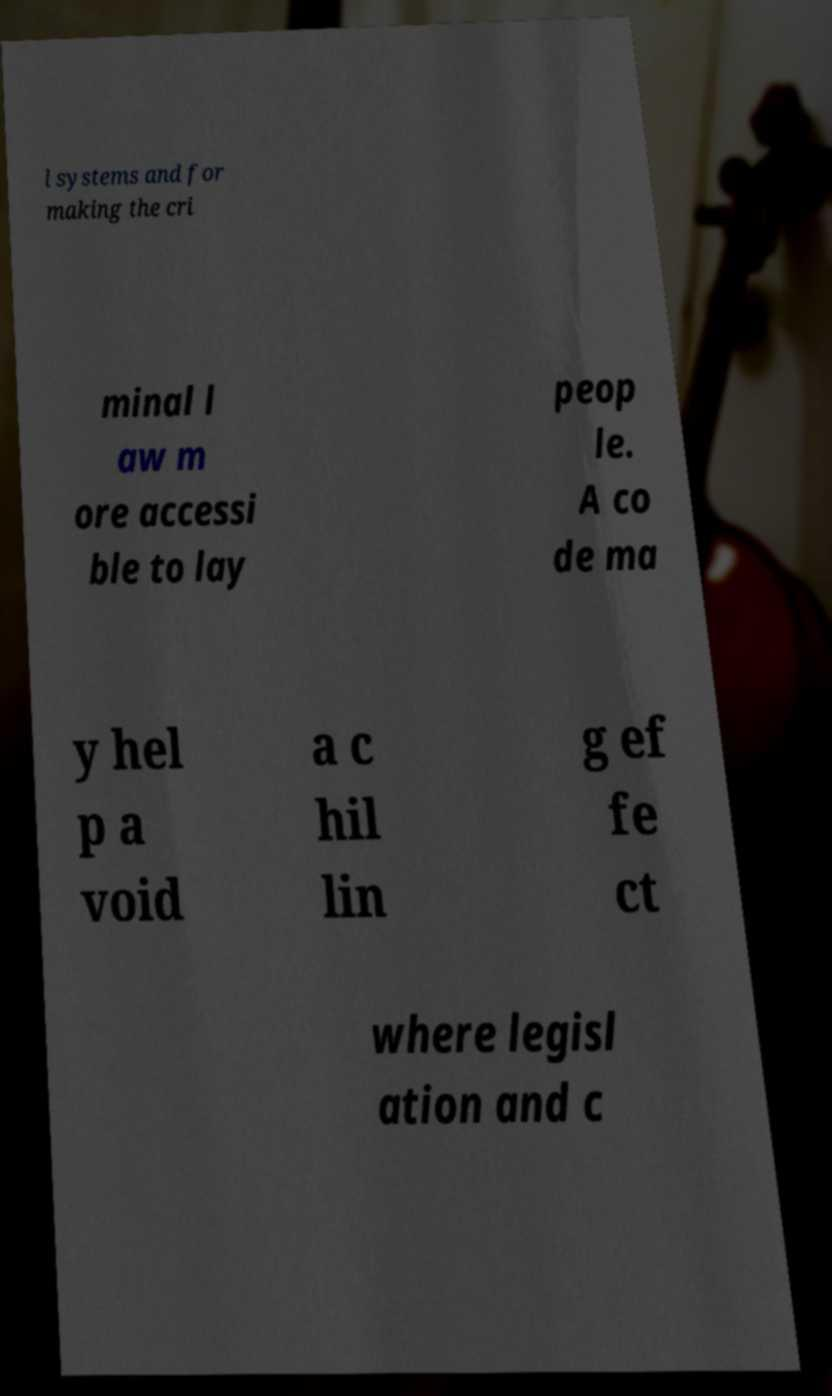What messages or text are displayed in this image? I need them in a readable, typed format. l systems and for making the cri minal l aw m ore accessi ble to lay peop le. A co de ma y hel p a void a c hil lin g ef fe ct where legisl ation and c 